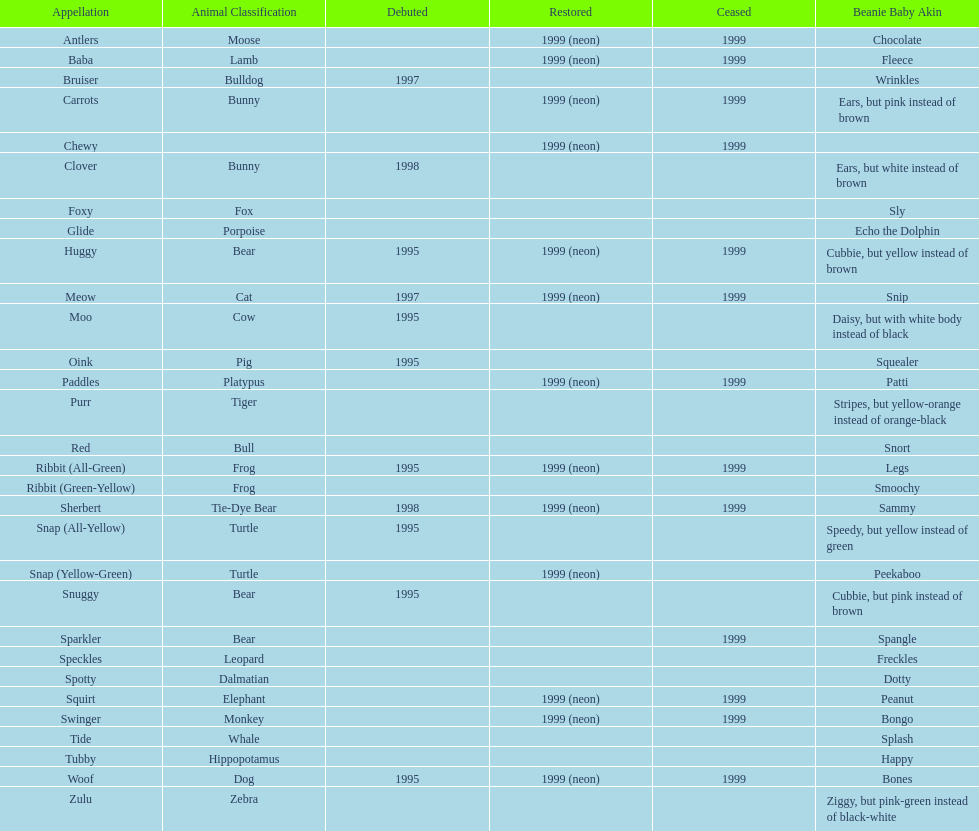Name the only pillow pal that is a dalmatian. Spotty. 